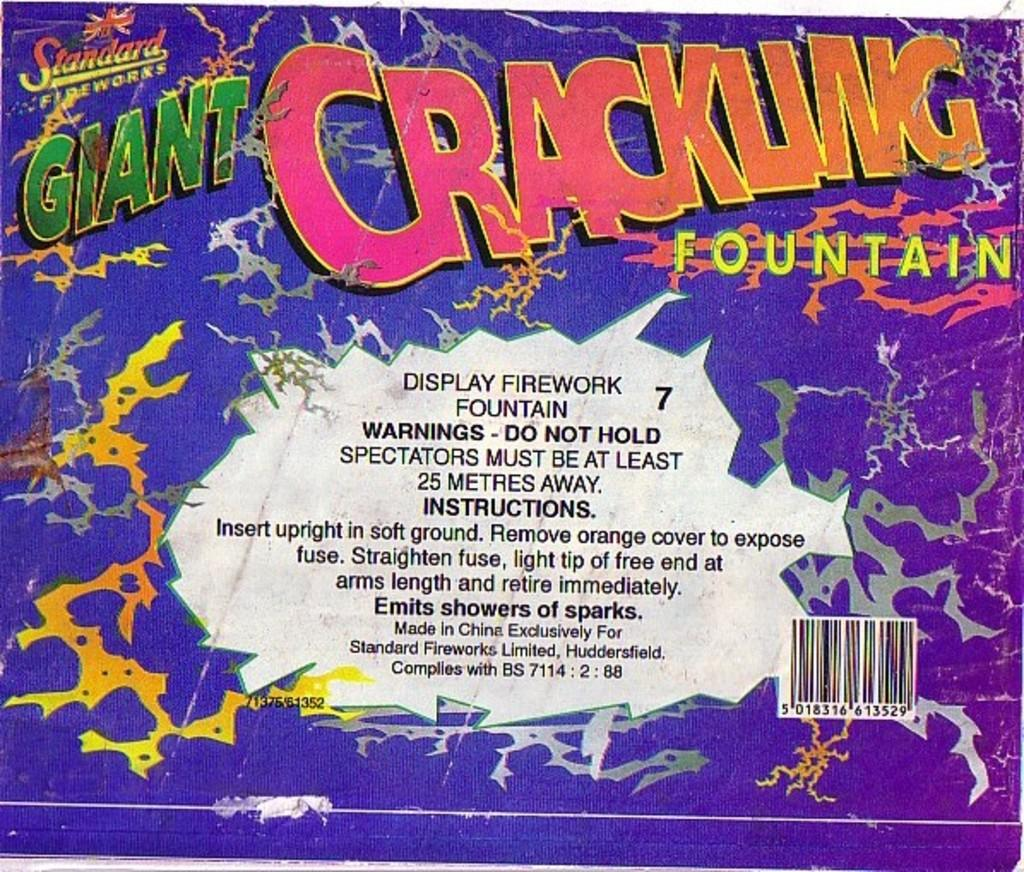<image>
Write a terse but informative summary of the picture. A box from a firework called the Giant Crackling Fountain. 